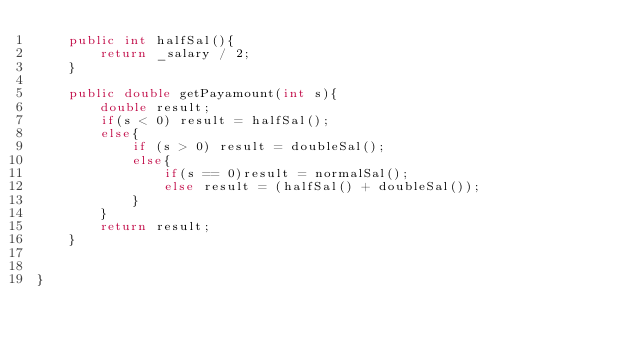<code> <loc_0><loc_0><loc_500><loc_500><_Java_>	public int halfSal(){
		return _salary / 2;
	}
	
	public double getPayamount(int s){
		double result;
		if(s < 0) result = halfSal();
		else{
			if (s > 0) result = doubleSal();
			else{
				if(s == 0)result = normalSal();
				else result = (halfSal() + doubleSal());
			}
		}
		return result;
	}
	

}
</code> 